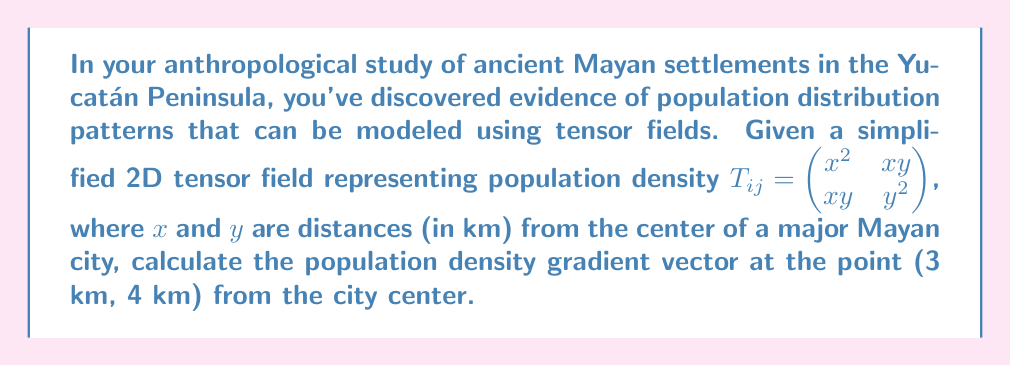Help me with this question. To solve this problem, we'll follow these steps:

1) The population density gradient is given by the divergence of the tensor field. In 2D, this is:

   $$\nabla \cdot T = \frac{\partial T_{xx}}{\partial x} + \frac{\partial T_{yy}}{\partial y}$$

2) We need to calculate $\frac{\partial T_{xx}}{\partial x}$ and $\frac{\partial T_{yy}}{\partial y}$:

   $T_{xx} = x^2$, so $\frac{\partial T_{xx}}{\partial x} = 2x$
   $T_{yy} = y^2$, so $\frac{\partial T_{yy}}{\partial y} = 2y$

3) The gradient vector is then:

   $$\nabla \cdot T = \begin{pmatrix} 2x \\ 2y \end{pmatrix}$$

4) At the point (3 km, 4 km), we substitute these values:

   $$\nabla \cdot T = \begin{pmatrix} 2(3) \\ 2(4) \end{pmatrix} = \begin{pmatrix} 6 \\ 8 \end{pmatrix}$$

5) This vector represents the direction and magnitude of the steepest increase in population density at the given point, measured in population per square kilometer per kilometer.
Answer: $(6, 8)$ km$^{-1}$ 